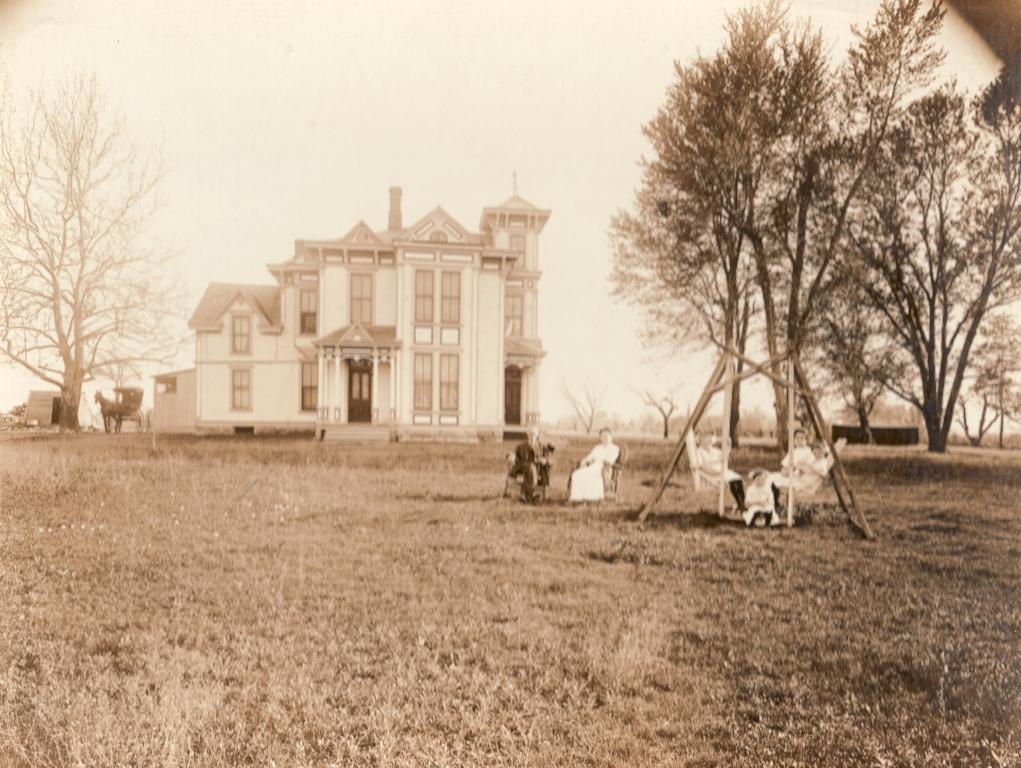What type of structure is present in the image? There is a building in the image. What natural elements can be seen in the image? There are trees and grass in the image. Who or what is present in the image? There are people and chairs in the image. What can be seen in the background of the image? The sky is visible in the background of the image. What type of cake is being kicked around by the people in the image? There is no cake present in the image, nor are the people kicking anything. What appliance is being used by the people in the image? There is no appliance visible in the image; the people are simply sitting on chairs. 